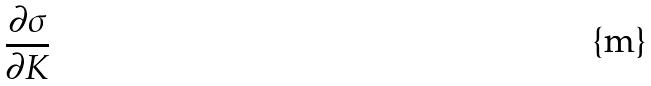<formula> <loc_0><loc_0><loc_500><loc_500>\frac { \partial \sigma } { \partial K }</formula> 